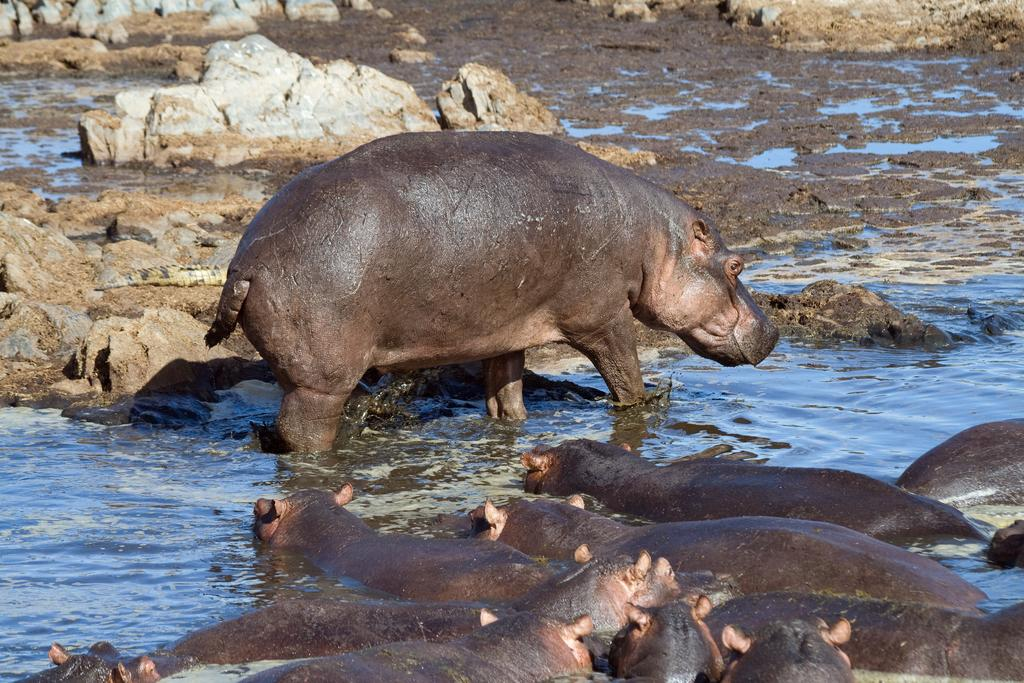What animals are in the water in the image? There are many hippopotamuses in the water. What else can be seen in the image besides the hippopotamuses? There are rocks visible in the image. How many balls are being juggled by the children in the image? There are no children or balls present in the image; it features hippopotamuses in the water and rocks. 